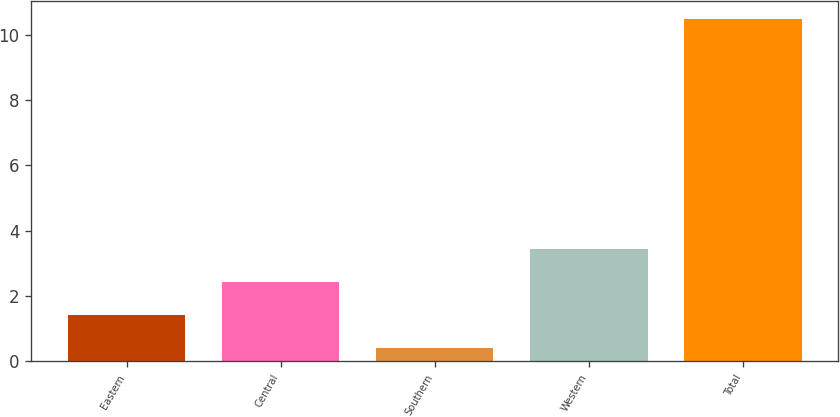Convert chart. <chart><loc_0><loc_0><loc_500><loc_500><bar_chart><fcel>Eastern<fcel>Central<fcel>Southern<fcel>Western<fcel>Total<nl><fcel>1.41<fcel>2.42<fcel>0.4<fcel>3.43<fcel>10.5<nl></chart> 